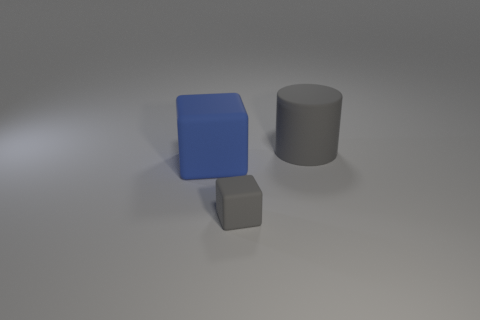The blue thing has what size?
Make the answer very short. Large. What number of shiny objects are either small red spheres or large blue things?
Your answer should be compact. 0. Are there fewer large cubes than tiny purple rubber things?
Offer a very short reply. No. What is the size of the other matte thing that is the same shape as the tiny gray object?
Provide a short and direct response. Large. Is the number of gray cylinders that are to the left of the small gray thing less than the number of small objects?
Give a very brief answer. Yes. Is there anything else that is the same shape as the tiny gray matte thing?
Ensure brevity in your answer.  Yes. The other matte thing that is the same shape as the tiny gray matte thing is what color?
Offer a very short reply. Blue. Do the matte block in front of the blue rubber cube and the big blue thing have the same size?
Give a very brief answer. No. What size is the gray thing in front of the large matte thing that is to the right of the large blue matte thing?
Your answer should be compact. Small. Are the small gray object and the block on the left side of the tiny rubber block made of the same material?
Ensure brevity in your answer.  Yes. 